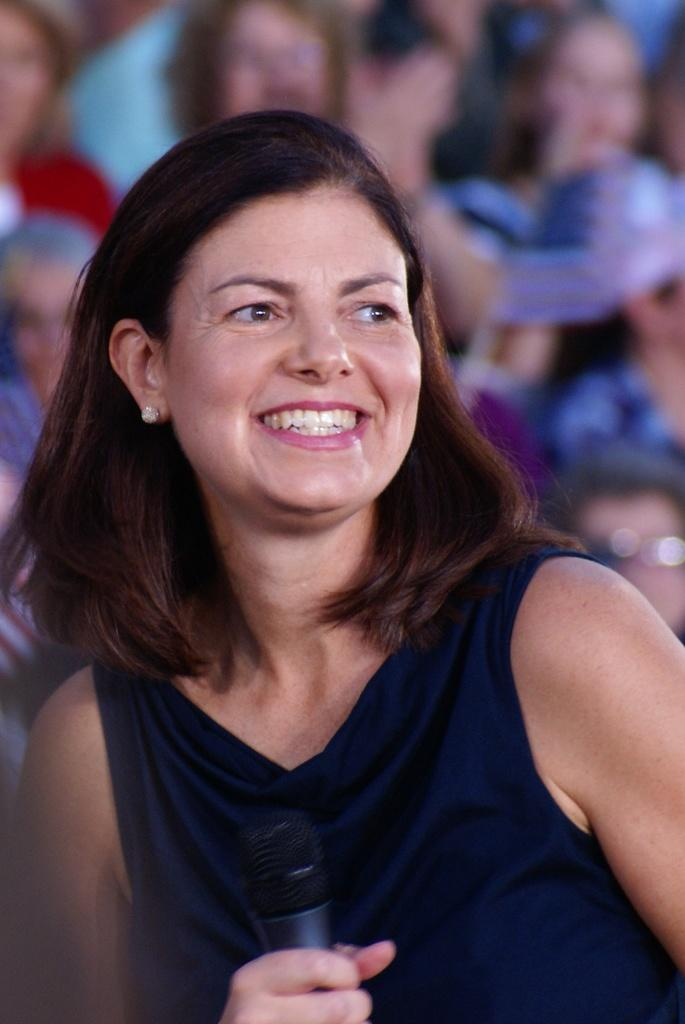Who is the main subject in the image? There is a woman in the image. What is the woman wearing? The woman is wearing a black T-shirt. What is the woman holding in the image? The woman is holding a microphone. What is the woman's facial expression? The woman is smiling. Can you describe the people in the background? There are people sitting in the background. How is the background of the image? The background is blurred. What type of cakes can be seen in the cave in the image? There is no cave or cakes present in the image; it features a woman holding a microphone and smiling. 